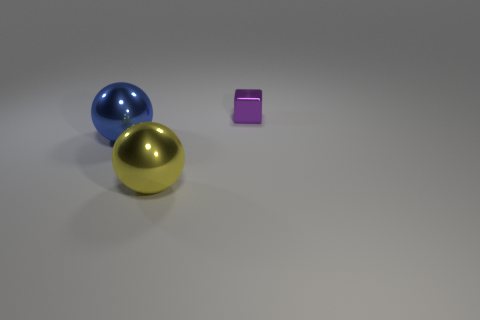Is there any other thing that is the same size as the purple block?
Make the answer very short. No. There is a shiny sphere that is left of the large shiny thing that is in front of the big metallic sphere that is behind the yellow shiny sphere; what size is it?
Offer a terse response. Large. How many other yellow balls are the same material as the big yellow ball?
Offer a very short reply. 0. How many yellow balls have the same size as the blue metallic ball?
Your answer should be compact. 1. There is a big thing that is behind the large thing that is in front of the object that is left of the big yellow metal thing; what is it made of?
Keep it short and to the point. Metal. What number of things are either blue things or yellow shiny things?
Ensure brevity in your answer.  2. Is there any other thing that has the same material as the big yellow ball?
Provide a succinct answer. Yes. What is the shape of the purple metallic thing?
Provide a short and direct response. Cube. What is the shape of the big metal thing that is on the right side of the big object that is behind the yellow metal object?
Make the answer very short. Sphere. Do the big thing that is right of the blue sphere and the tiny purple thing have the same material?
Your answer should be very brief. Yes. 